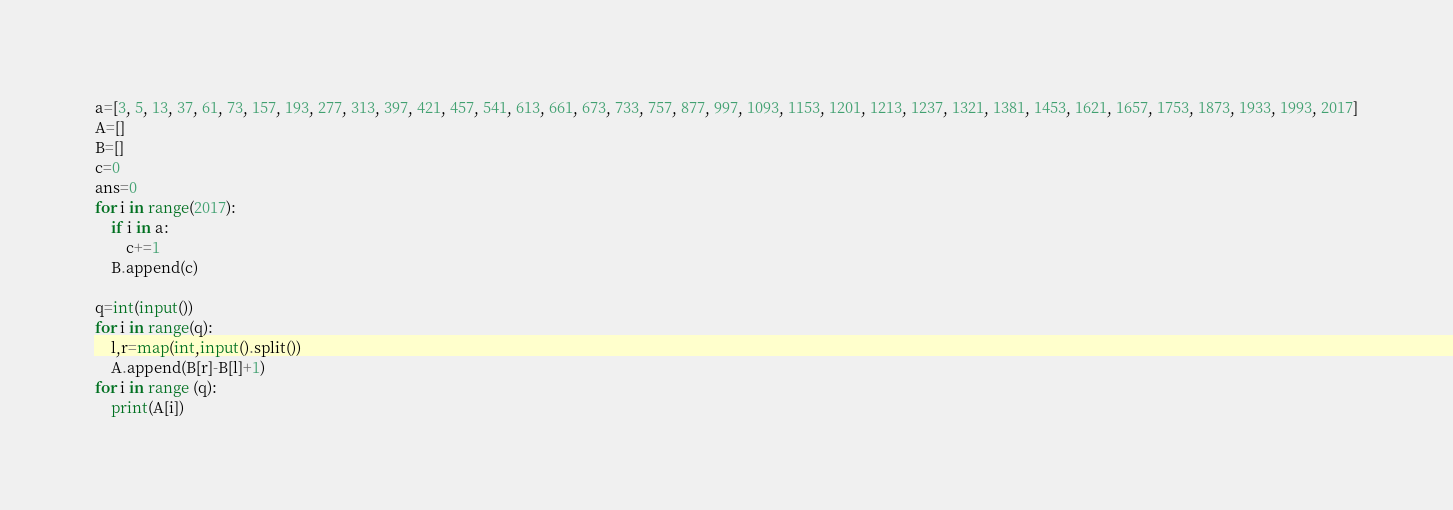Convert code to text. <code><loc_0><loc_0><loc_500><loc_500><_Python_>a=[3, 5, 13, 37, 61, 73, 157, 193, 277, 313, 397, 421, 457, 541, 613, 661, 673, 733, 757, 877, 997, 1093, 1153, 1201, 1213, 1237, 1321, 1381, 1453, 1621, 1657, 1753, 1873, 1933, 1993, 2017]
A=[]
B=[]
c=0
ans=0
for i in range(2017):
    if i in a:
        c+=1
    B.append(c)
    
q=int(input())
for i in range(q):
    l,r=map(int,input().split())
    A.append(B[r]-B[l]+1)
for i in range (q):
    print(A[i])</code> 